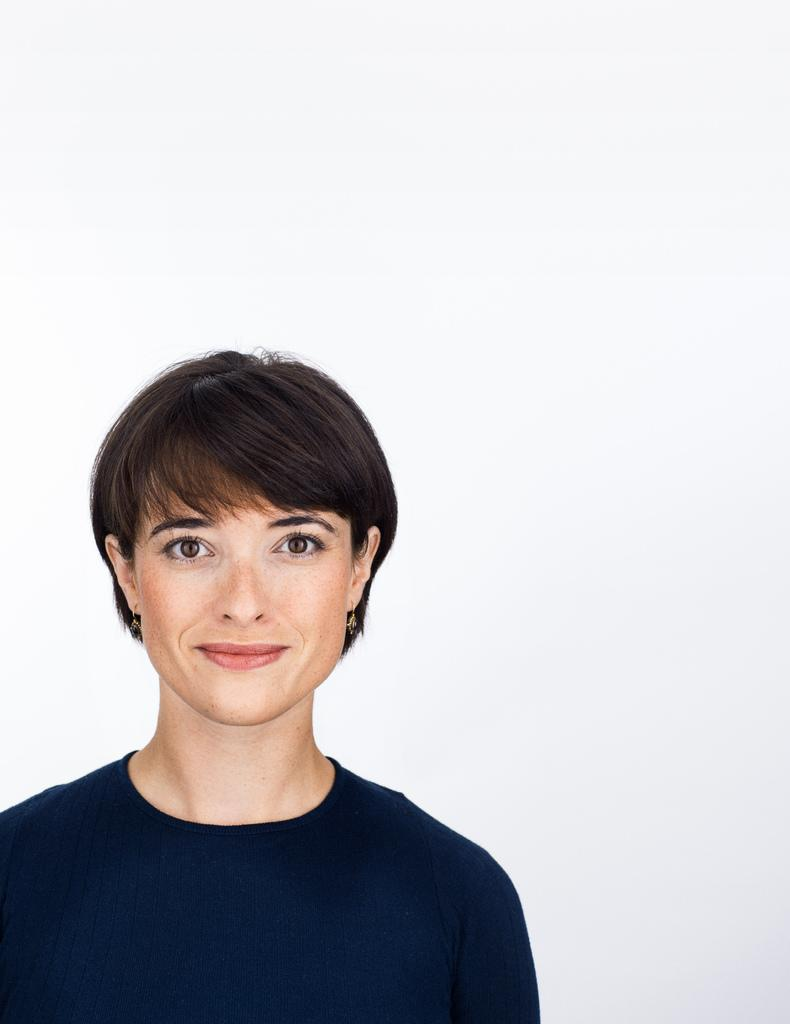What is the main subject of the image? There is a lady in the image. What is the lady wearing in the image? The lady is wearing a black T-shirt. What type of health advice can be seen on the lady's T-shirt in the image? There is no indication of any health advice or information on the lady's T-shirt in the image. What type of bell is hanging around the lady's neck in the image? There is no bell present around the lady's neck in the image. 